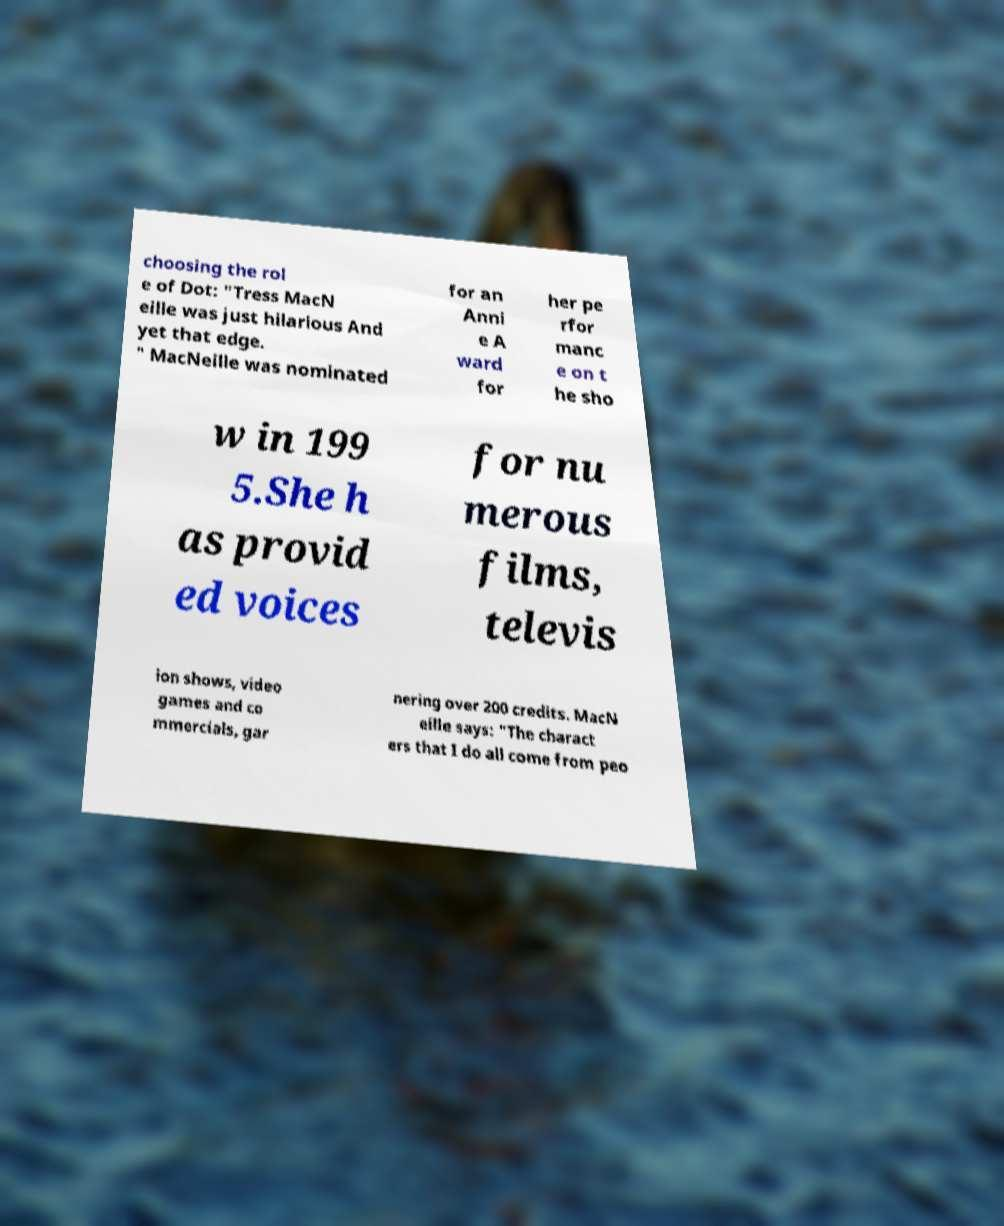Can you read and provide the text displayed in the image?This photo seems to have some interesting text. Can you extract and type it out for me? choosing the rol e of Dot: "Tress MacN eille was just hilarious And yet that edge. " MacNeille was nominated for an Anni e A ward for her pe rfor manc e on t he sho w in 199 5.She h as provid ed voices for nu merous films, televis ion shows, video games and co mmercials, gar nering over 200 credits. MacN eille says: "The charact ers that I do all come from peo 